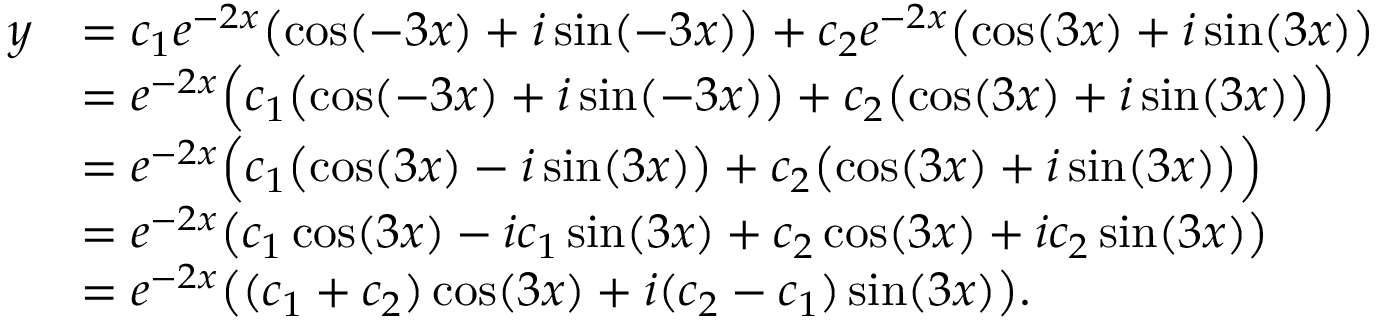Convert formula to latex. <formula><loc_0><loc_0><loc_500><loc_500>\begin{array} { r l } { y } & { = c _ { 1 } e ^ { - 2 x } \left ( \cos ( - 3 x ) + i \sin ( - 3 x ) \right ) + c _ { 2 } e ^ { - 2 x } \left ( \cos ( 3 x ) + i \sin ( 3 x ) \right ) } \\ & { = e ^ { - 2 x } \left ( c _ { 1 } \left ( \cos ( - 3 x ) + i \sin ( - 3 x ) \right ) + c _ { 2 } \left ( \cos ( 3 x ) + i \sin ( 3 x ) \right ) \right ) } \\ & { = e ^ { - 2 x } \left ( c _ { 1 } \left ( \cos ( 3 x ) - i \sin ( 3 x ) \right ) + c _ { 2 } \left ( \cos ( 3 x ) + i \sin ( 3 x ) \right ) \right ) } \\ & { = e ^ { - 2 x } \left ( c _ { 1 } \cos ( 3 x ) - i c _ { 1 } \sin ( 3 x ) + c _ { 2 } \cos ( 3 x ) + i c _ { 2 } \sin ( 3 x ) \right ) } \\ & { = e ^ { - 2 x } \left ( ( c _ { 1 } + c _ { 2 } ) \cos ( 3 x ) + i ( c _ { 2 } - c _ { 1 } ) \sin ( 3 x ) \right ) . } \end{array}</formula> 